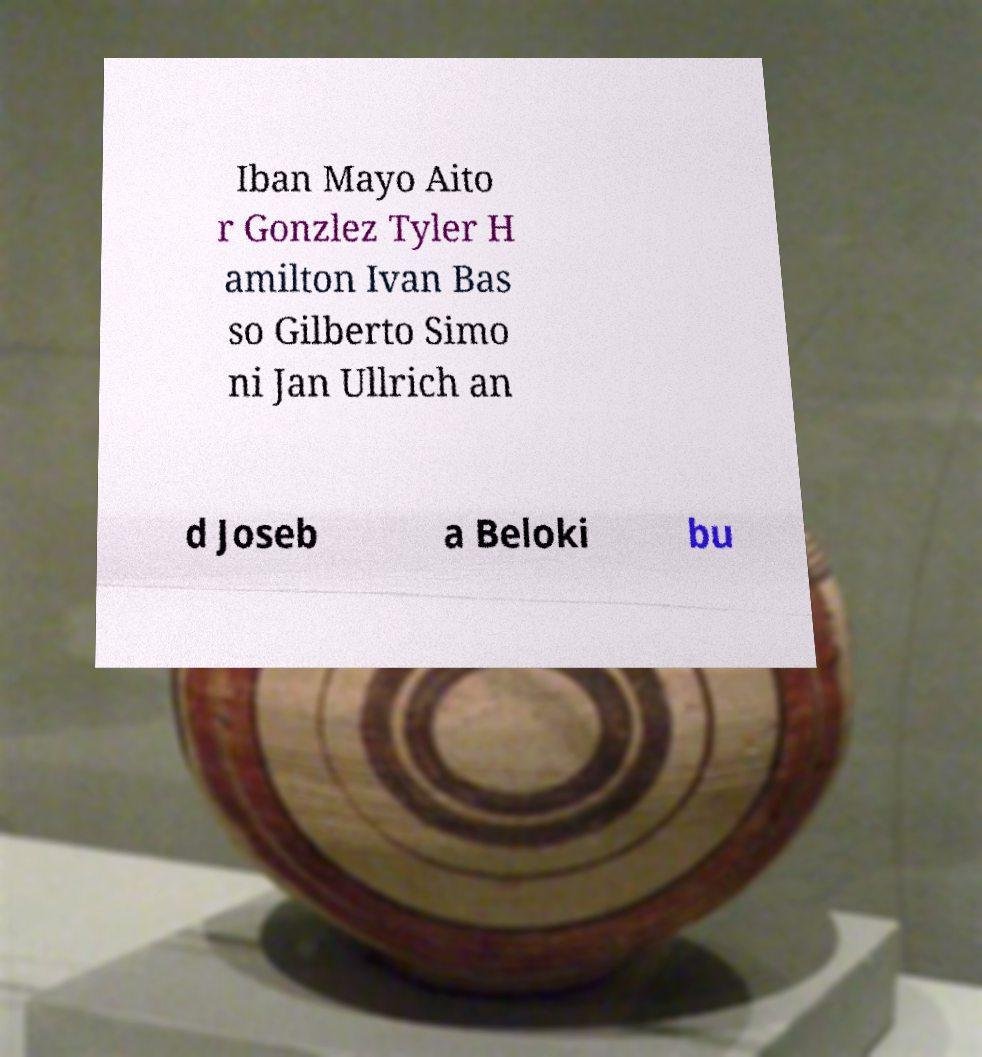Could you assist in decoding the text presented in this image and type it out clearly? Iban Mayo Aito r Gonzlez Tyler H amilton Ivan Bas so Gilberto Simo ni Jan Ullrich an d Joseb a Beloki bu 